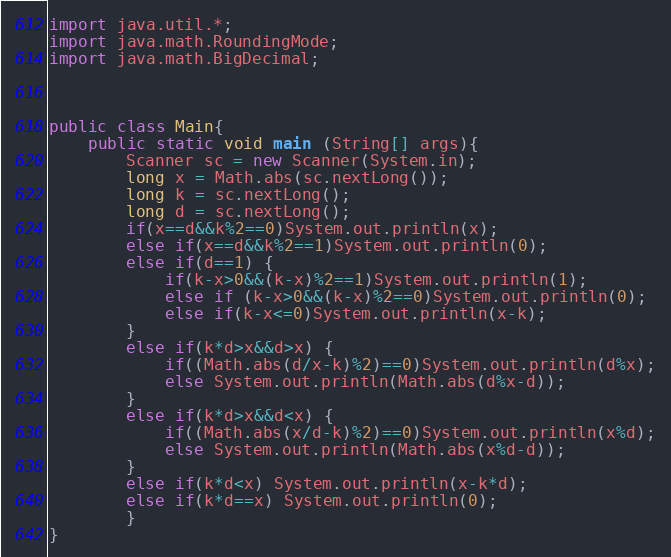Convert code to text. <code><loc_0><loc_0><loc_500><loc_500><_Java_>import java.util.*;
import java.math.RoundingMode;
import java.math.BigDecimal;
 
 
 
public class Main{
	public static void main (String[] args){
		Scanner sc = new Scanner(System.in);
		long x = Math.abs(sc.nextLong());
		long k = sc.nextLong();
		long d = sc.nextLong();
		if(x==d&&k%2==0)System.out.println(x);
		else if(x==d&&k%2==1)System.out.println(0);
		else if(d==1) {
			if(k-x>0&&(k-x)%2==1)System.out.println(1);
			else if (k-x>0&&(k-x)%2==0)System.out.println(0);
			else if(k-x<=0)System.out.println(x-k);
		}
		else if(k*d>x&&d>x) {
			if((Math.abs(d/x-k)%2)==0)System.out.println(d%x);
			else System.out.println(Math.abs(d%x-d));
		}
		else if(k*d>x&&d<x) {
			if((Math.abs(x/d-k)%2)==0)System.out.println(x%d);
			else System.out.println(Math.abs(x%d-d));
		}
		else if(k*d<x) System.out.println(x-k*d);
		else if(k*d==x) System.out.println(0);
		}
}</code> 